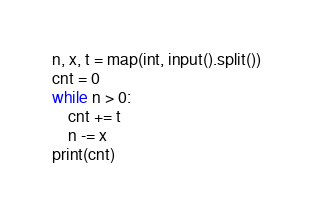<code> <loc_0><loc_0><loc_500><loc_500><_Python_>n, x, t = map(int, input().split())
cnt = 0
while n > 0:
    cnt += t
    n -= x
print(cnt)
</code> 